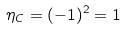<formula> <loc_0><loc_0><loc_500><loc_500>\eta _ { C } = ( - 1 ) ^ { 2 } = 1</formula> 